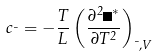<formula> <loc_0><loc_0><loc_500><loc_500>c _ { \mu } = - \frac { T } { L } \left ( \frac { \partial ^ { 2 } \Omega ^ { * } } { \partial T ^ { 2 } } \right ) _ { \mu , V }</formula> 